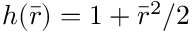<formula> <loc_0><loc_0><loc_500><loc_500>h ( \bar { r } ) = 1 + { \bar { r } } ^ { 2 } / 2</formula> 